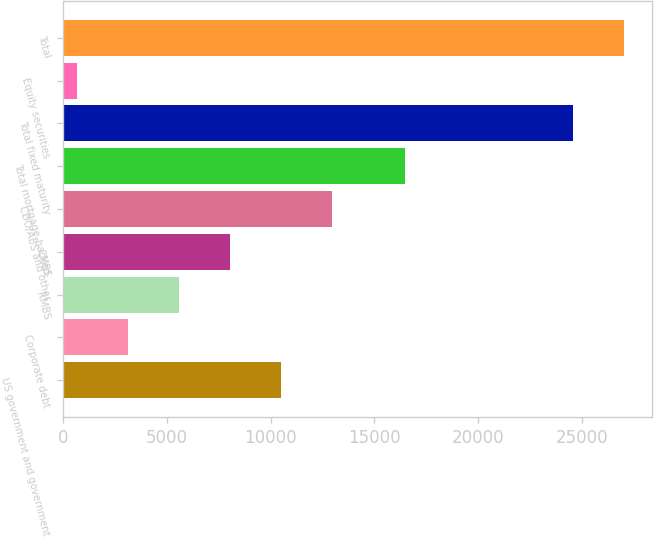<chart> <loc_0><loc_0><loc_500><loc_500><bar_chart><fcel>US government and government<fcel>Corporate debt<fcel>RMBS<fcel>CMBS<fcel>CDO/ABS and other<fcel>Total mortgage-backed<fcel>Total fixed maturity<fcel>Equity securities<fcel>Total<nl><fcel>10495.6<fcel>3120.4<fcel>5578.8<fcel>8037.2<fcel>12954<fcel>16460<fcel>24584<fcel>662<fcel>27042.4<nl></chart> 